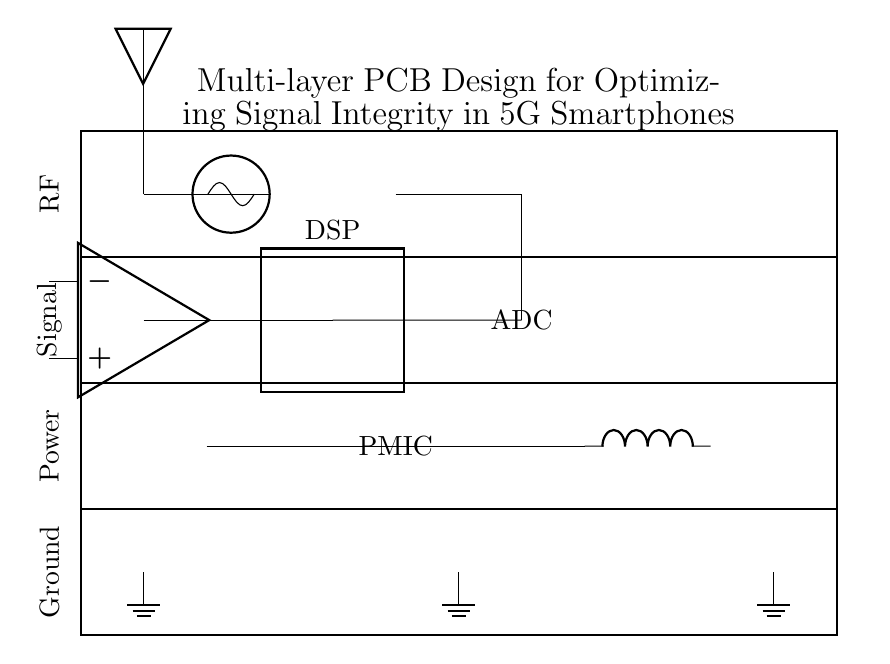What is the highest layer in the PCB design? The highest layer in the PCB design is the RF layer, which is represented at the topmost position in the diagram. The layers are organized from Ground at the bottom to RF at the top, making RF the highest layer.
Answer: RF What type of component is used for power management? The power management component in the diagram is represented as a PMIC (Power Management Integrated Circuit), which is connected to the power layer. It is essential for managing the power supply to the device.
Answer: PMIC How many layers are depicted in the PCB design? The PCB design clearly shows four layers: Ground, Power, Signal, and RF, indicated by horizontal lines separating each section in the diagram.
Answer: Four Which component is labeled as 'LO'? The component labeled as 'LO' is an oscillator, which is essential for generating local oscillator signals in RF applications, as shown in the RF layer.
Answer: Oscillator What is the function of the DSP in this circuit? The DSP (Digital Signal Processor) in this circuit processes the signals after they have been converted by the ADC (Analog-to-Digital Converter). The DSP enhances signal integrity for better performance in 5G smartphones.
Answer: Signal processing Describe the connection between the signal layer and the RF layer. The connection between the signal layer and the RF layer is facilitated by a direct line drawn from the lower signal layer to the RF components, indicating that signals are directed upwards to interface with the RF components.
Answer: Direct connection Where does the power come from in this PCB design? The power source in the PCB design comes from a battery located in the power layer. The battery connects to the PMIC to distribute power throughout the circuit.
Answer: Battery 